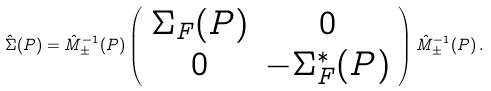<formula> <loc_0><loc_0><loc_500><loc_500>\hat { \Sigma } ( P ) = \hat { M } _ { \pm } ^ { - 1 } ( P ) \left ( \begin{array} { c c } \Sigma _ { F } ( P ) & 0 \\ 0 & - \Sigma ^ { * } _ { F } ( P ) \end{array} \right ) \hat { M } _ { \pm } ^ { - 1 } ( P ) \, .</formula> 